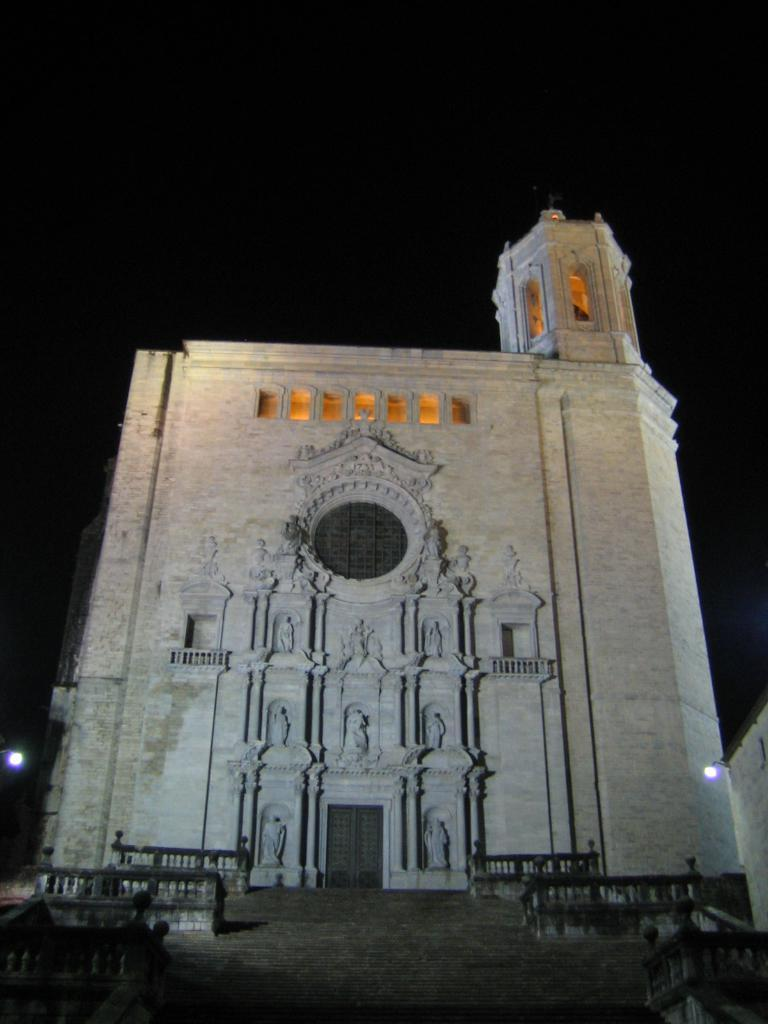What type of structure is visible in the image? There is a building in the image. What can be seen illuminating the area in the image? There are street lights in the image. What is visible in the background of the image? The sky is visible in the background of the image. What architectural feature is present in the image? There are steps in the image. Can you describe any other objects present in the image? There are other objects present in the image, but their specific details are not mentioned in the provided facts. How many lizards are sitting on the building in the image? There are no lizards present in the image. What type of smoke can be seen coming from the building in the image? There is no smoke visible in the image. 